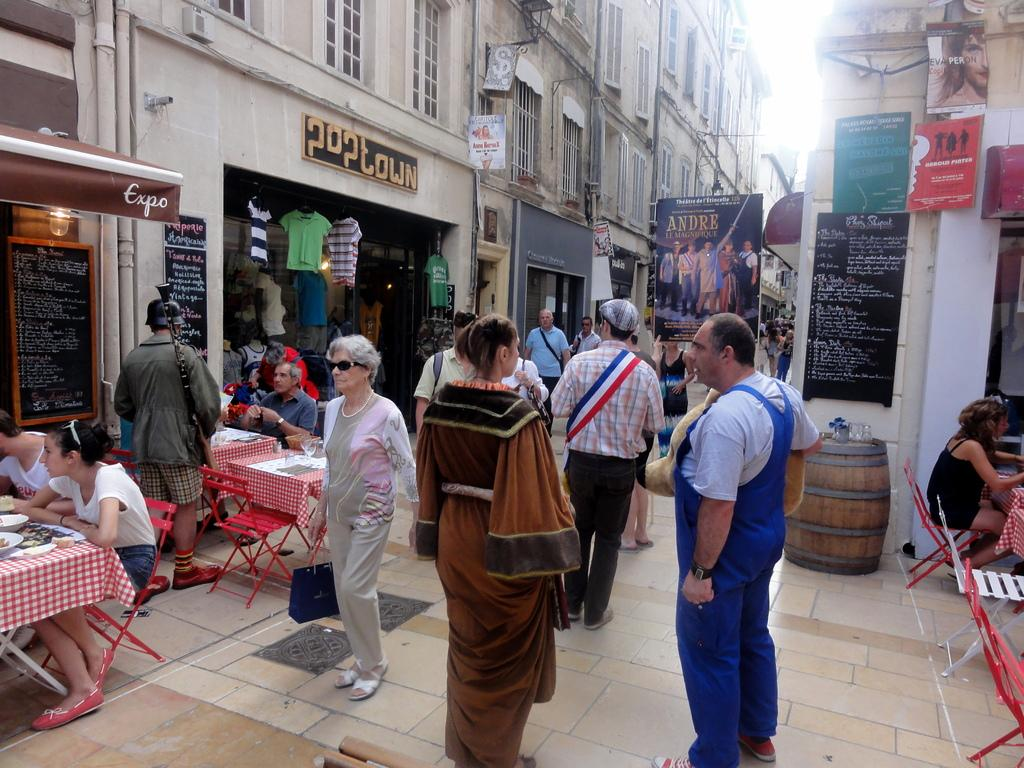How many people are in the image? There is a group of people in the image, but the exact number is not specified. Where are the people located? The people are in a street. What furniture is present on one side of the street? There are tables and chairs on one side of the street. What type of machine is being used by the people in the image? There is no machine visible in the image; it only shows a group of people in a street with tables and chairs on one side. 